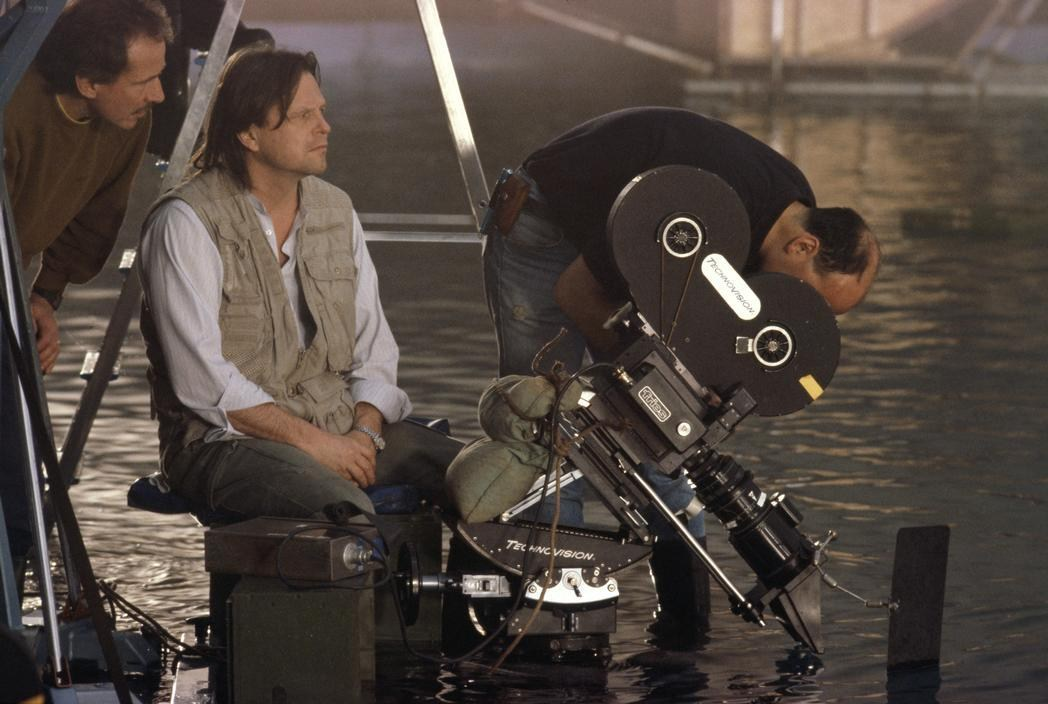How might the filmmakers ensure the camera and equipment are protected during this shoot? To ensure the camera and equipment are protected during this shoot, the filmmakers would employ several technical and practical strategies. The camera might be housed in a waterproof casing to prevent any water damage, while also ensuring that it remains functional and stable. Additionally, electrical connections and other sensitive equipment would be secured and insulated against moisture. Protective gear for the crew, such as waterproof boots and clothing, would be essential to maintain safety and efficiency during the shoot. They might also have backup equipment ready and a team of technicians on hand to address any issues that arise promptly. What might happen if a sudden storm hits the filming location? If a sudden storm hits the filming location, the crew would need to act quickly to secure all equipment and ensure the safety of everyone on set. They would likely have pre-planned protocols for such events, including moving sensitive equipment to a dry, secure area and possibly suspending filming until the storm passes. Safety harnesses, tarps, and temporary shelters might be utilized to protect both the crew and gear from heavy rain and strong winds. The storm itself could also present an opportunity to capture dramatic and realistic footage that adds to the intensity of the scene if done safely. 